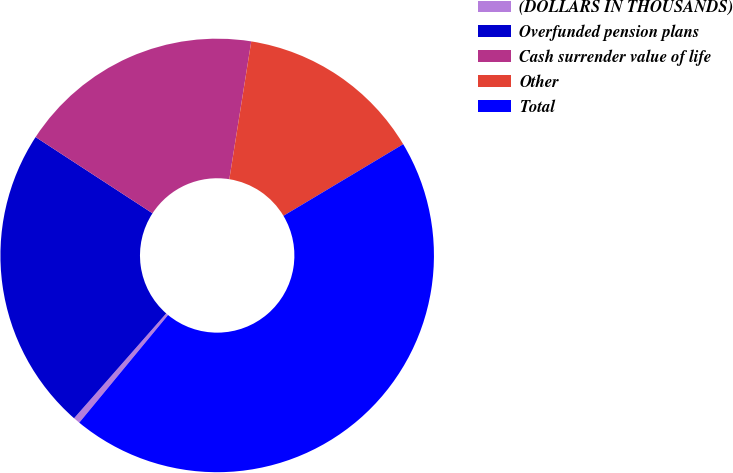Convert chart. <chart><loc_0><loc_0><loc_500><loc_500><pie_chart><fcel>(DOLLARS IN THOUSANDS)<fcel>Overfunded pension plans<fcel>Cash surrender value of life<fcel>Other<fcel>Total<nl><fcel>0.5%<fcel>22.72%<fcel>18.32%<fcel>13.91%<fcel>44.56%<nl></chart> 